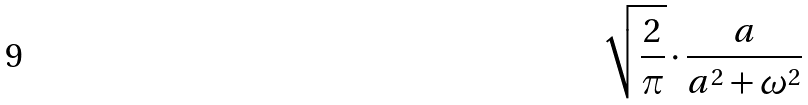<formula> <loc_0><loc_0><loc_500><loc_500>\sqrt { \frac { 2 } { \pi } } \cdot \frac { a } { a ^ { 2 } + \omega ^ { 2 } }</formula> 